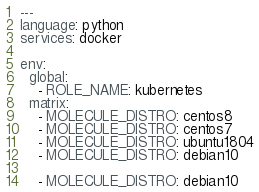Convert code to text. <code><loc_0><loc_0><loc_500><loc_500><_YAML_>---
language: python
services: docker

env:
  global:
    - ROLE_NAME: kubernetes
  matrix:
    - MOLECULE_DISTRO: centos8
    - MOLECULE_DISTRO: centos7
    - MOLECULE_DISTRO: ubuntu1804
    - MOLECULE_DISTRO: debian10

    - MOLECULE_DISTRO: debian10</code> 